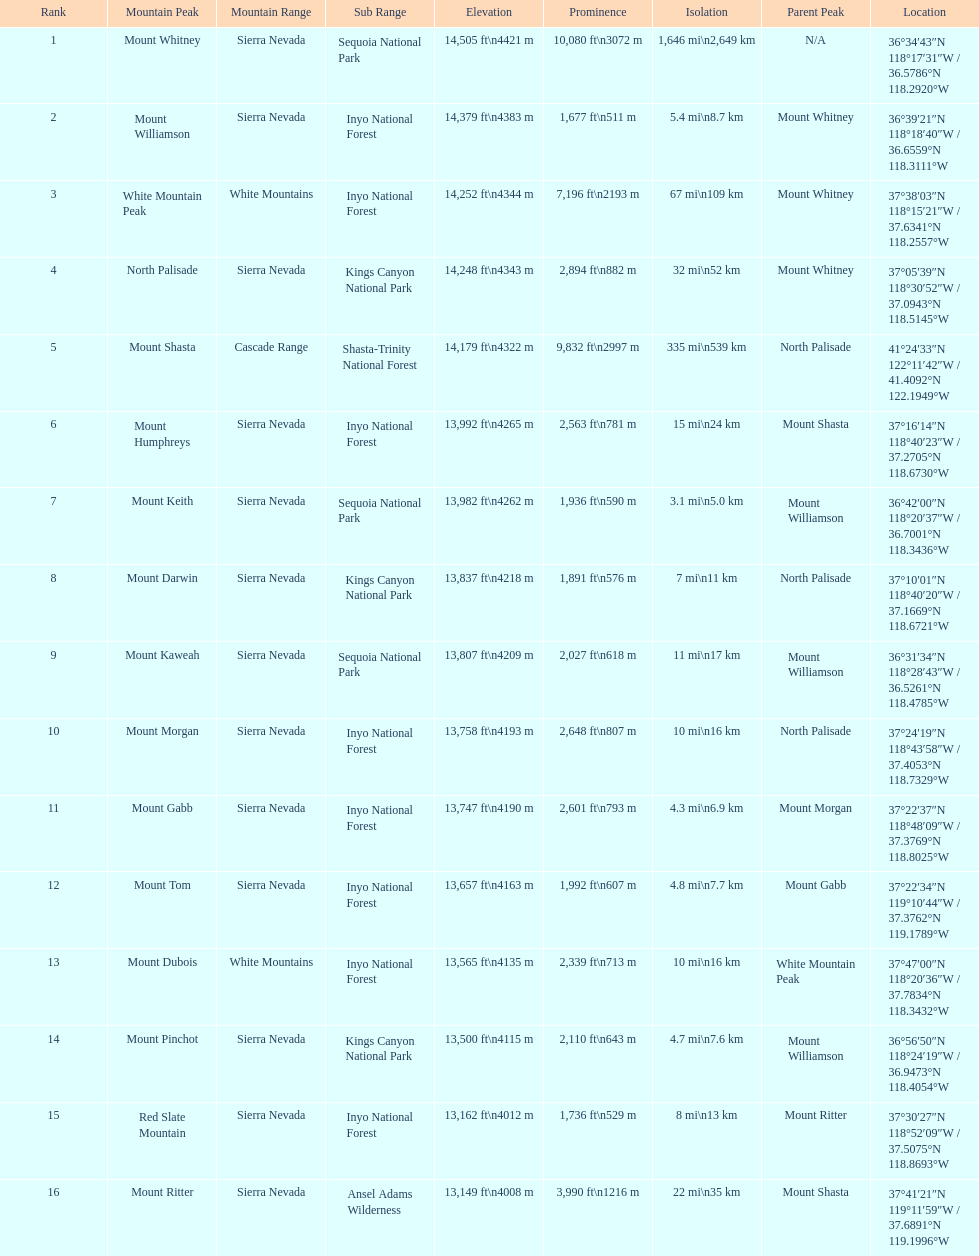What is the tallest peak in the sierra nevadas? Mount Whitney. 